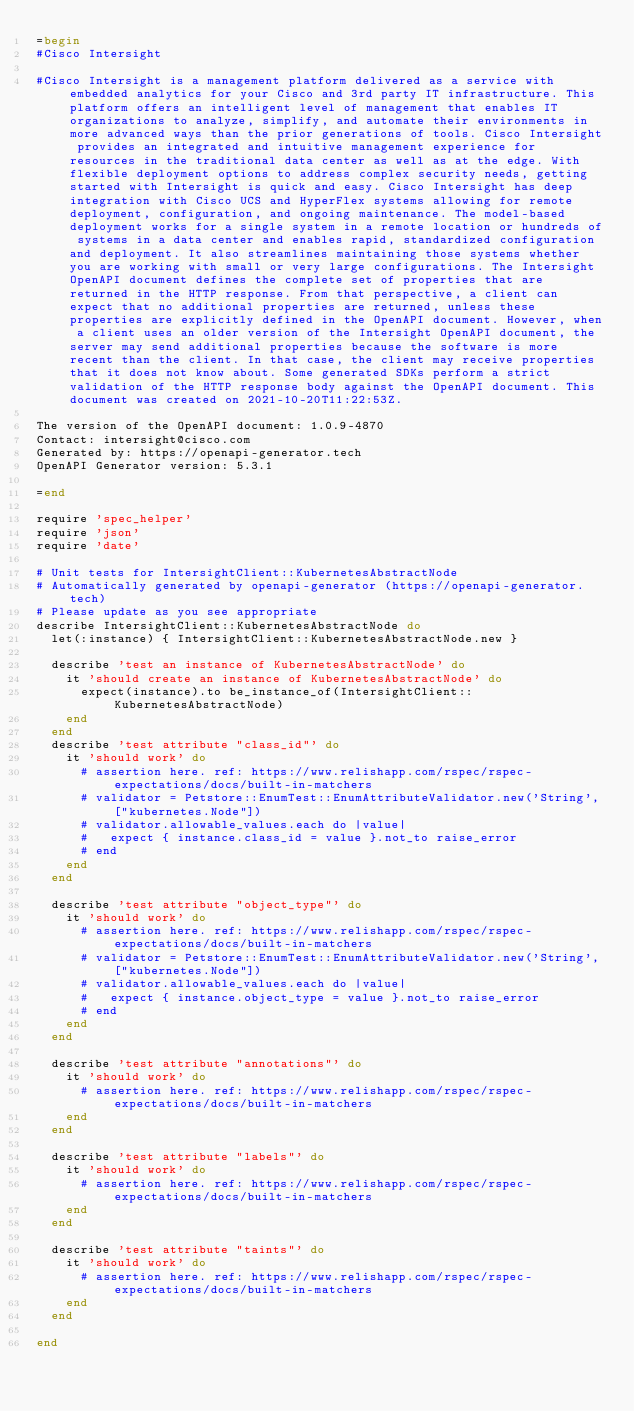<code> <loc_0><loc_0><loc_500><loc_500><_Ruby_>=begin
#Cisco Intersight

#Cisco Intersight is a management platform delivered as a service with embedded analytics for your Cisco and 3rd party IT infrastructure. This platform offers an intelligent level of management that enables IT organizations to analyze, simplify, and automate their environments in more advanced ways than the prior generations of tools. Cisco Intersight provides an integrated and intuitive management experience for resources in the traditional data center as well as at the edge. With flexible deployment options to address complex security needs, getting started with Intersight is quick and easy. Cisco Intersight has deep integration with Cisco UCS and HyperFlex systems allowing for remote deployment, configuration, and ongoing maintenance. The model-based deployment works for a single system in a remote location or hundreds of systems in a data center and enables rapid, standardized configuration and deployment. It also streamlines maintaining those systems whether you are working with small or very large configurations. The Intersight OpenAPI document defines the complete set of properties that are returned in the HTTP response. From that perspective, a client can expect that no additional properties are returned, unless these properties are explicitly defined in the OpenAPI document. However, when a client uses an older version of the Intersight OpenAPI document, the server may send additional properties because the software is more recent than the client. In that case, the client may receive properties that it does not know about. Some generated SDKs perform a strict validation of the HTTP response body against the OpenAPI document. This document was created on 2021-10-20T11:22:53Z.

The version of the OpenAPI document: 1.0.9-4870
Contact: intersight@cisco.com
Generated by: https://openapi-generator.tech
OpenAPI Generator version: 5.3.1

=end

require 'spec_helper'
require 'json'
require 'date'

# Unit tests for IntersightClient::KubernetesAbstractNode
# Automatically generated by openapi-generator (https://openapi-generator.tech)
# Please update as you see appropriate
describe IntersightClient::KubernetesAbstractNode do
  let(:instance) { IntersightClient::KubernetesAbstractNode.new }

  describe 'test an instance of KubernetesAbstractNode' do
    it 'should create an instance of KubernetesAbstractNode' do
      expect(instance).to be_instance_of(IntersightClient::KubernetesAbstractNode)
    end
  end
  describe 'test attribute "class_id"' do
    it 'should work' do
      # assertion here. ref: https://www.relishapp.com/rspec/rspec-expectations/docs/built-in-matchers
      # validator = Petstore::EnumTest::EnumAttributeValidator.new('String', ["kubernetes.Node"])
      # validator.allowable_values.each do |value|
      #   expect { instance.class_id = value }.not_to raise_error
      # end
    end
  end

  describe 'test attribute "object_type"' do
    it 'should work' do
      # assertion here. ref: https://www.relishapp.com/rspec/rspec-expectations/docs/built-in-matchers
      # validator = Petstore::EnumTest::EnumAttributeValidator.new('String', ["kubernetes.Node"])
      # validator.allowable_values.each do |value|
      #   expect { instance.object_type = value }.not_to raise_error
      # end
    end
  end

  describe 'test attribute "annotations"' do
    it 'should work' do
      # assertion here. ref: https://www.relishapp.com/rspec/rspec-expectations/docs/built-in-matchers
    end
  end

  describe 'test attribute "labels"' do
    it 'should work' do
      # assertion here. ref: https://www.relishapp.com/rspec/rspec-expectations/docs/built-in-matchers
    end
  end

  describe 'test attribute "taints"' do
    it 'should work' do
      # assertion here. ref: https://www.relishapp.com/rspec/rspec-expectations/docs/built-in-matchers
    end
  end

end
</code> 